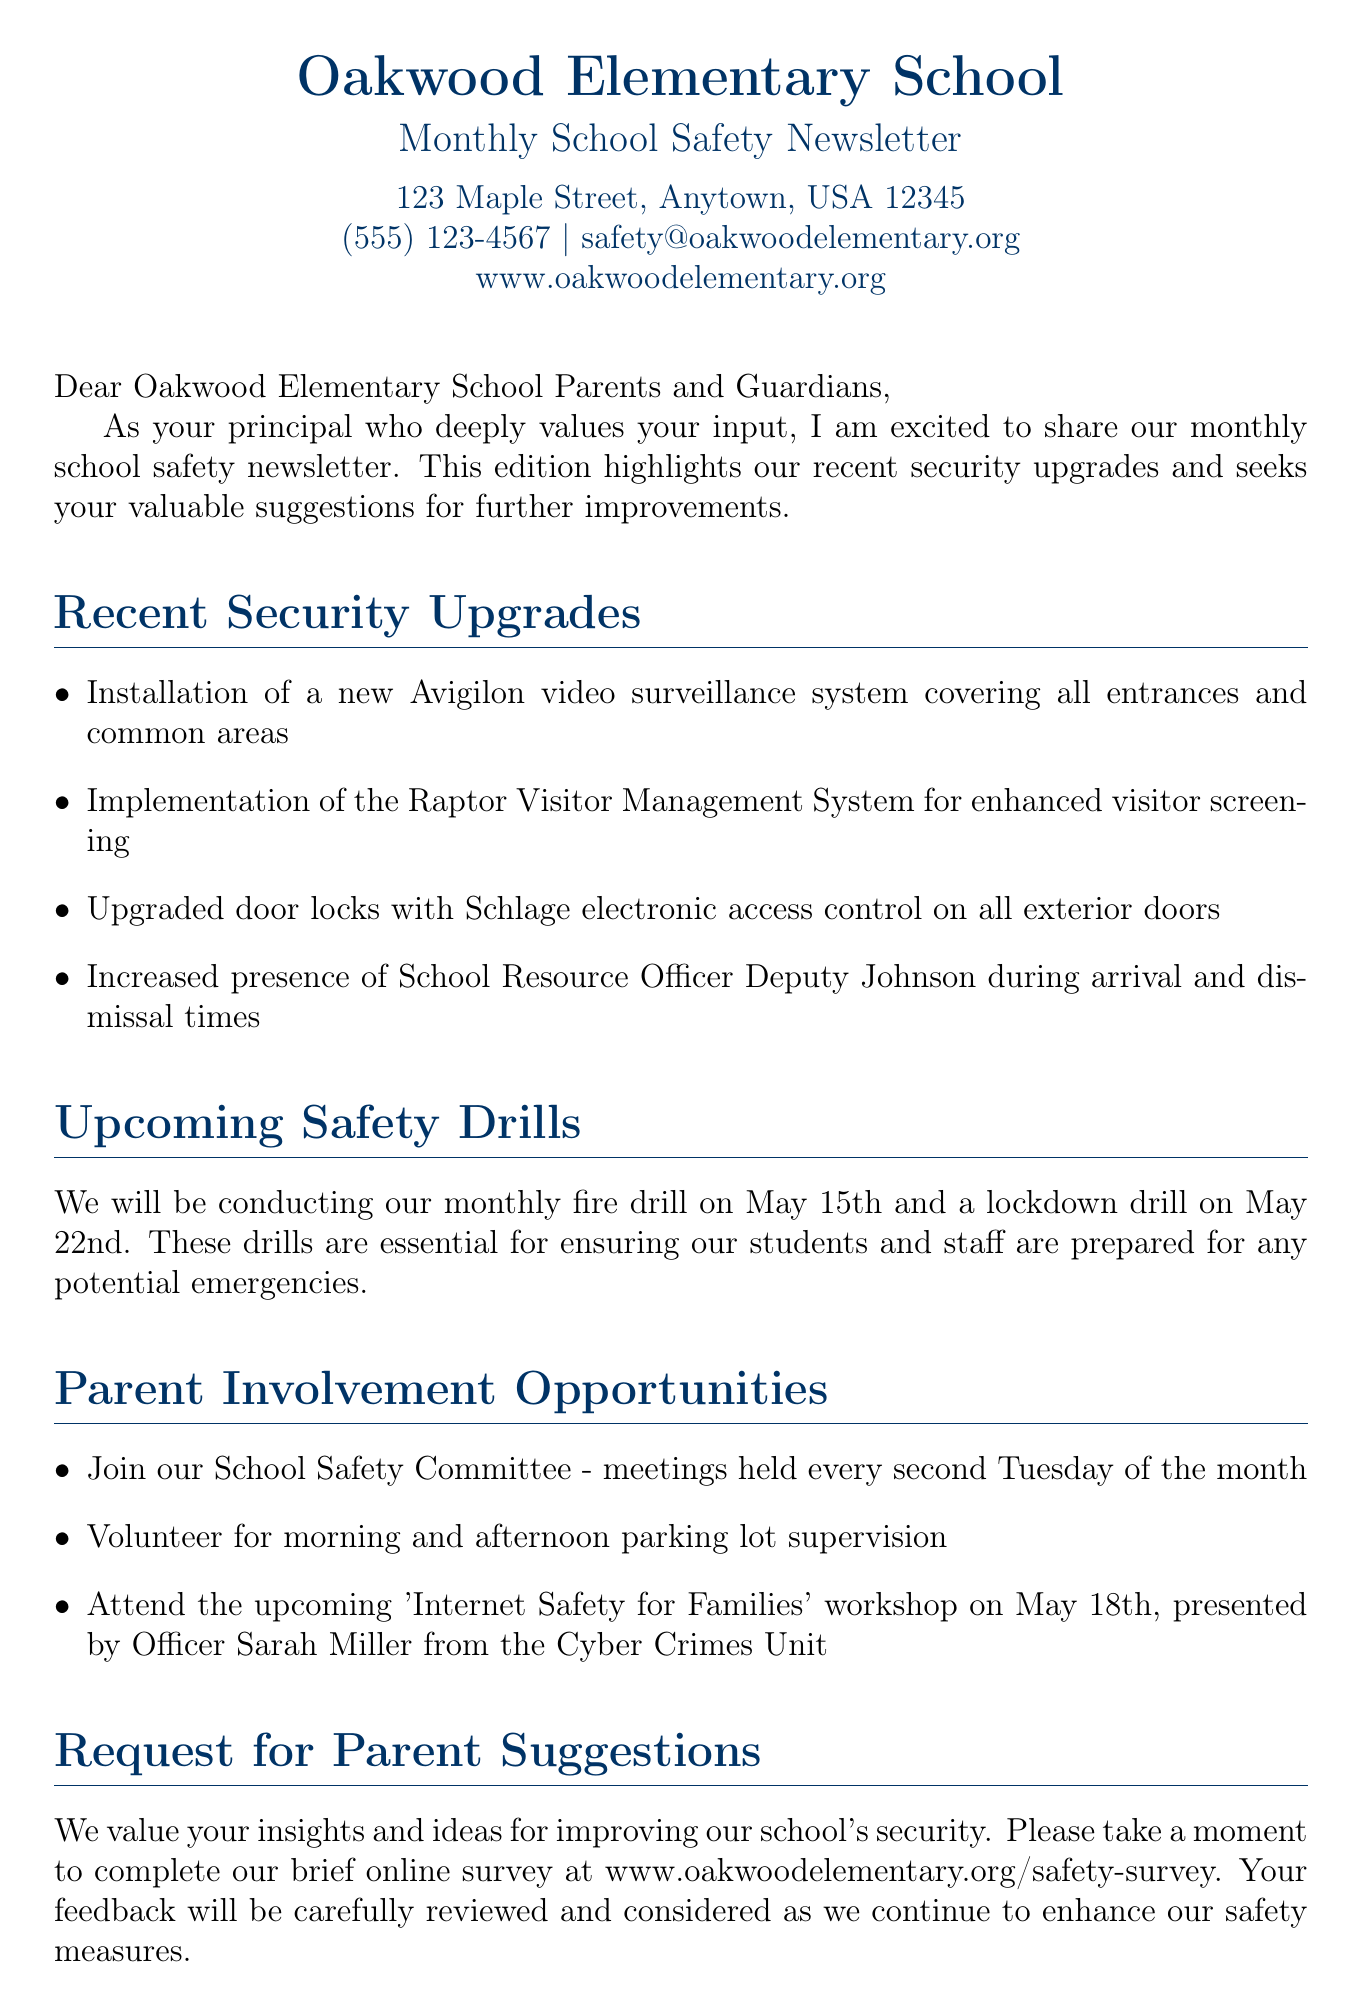What is the date of the fire drill? The fire drill is scheduled for May 15th, as mentioned in the Upcoming Safety Drills section.
Answer: May 15th Who is the School Resource Officer? The document states that Deputy Johnson is the School Resource Officer present during arrival and dismissal times.
Answer: Deputy Johnson What is the new visitor management system called? The document mentions the implementation of the Raptor Visitor Management System for enhanced visitor screening.
Answer: Raptor Visitor Management System When is the Internet Safety for Families workshop? The workshop is scheduled for May 18th, as indicated in the Parent Involvement Opportunities section.
Answer: May 18th What type of assessment is Secure Schools Alliance conducting? The newsletter states that Secure Schools Alliance will conduct a comprehensive safety assessment of our campus.
Answer: Comprehensive safety assessment How often does the School Safety Committee meet? The document notes that the School Safety Committee meets every second Tuesday of the month.
Answer: Every second Tuesday What method will parents use to provide security suggestions? The letter includes a brief online survey at a specified URL for parents to provide their feedback and suggestions.
Answer: Online survey How many recent security upgrades are listed? The letter outlines four recent security upgrades implemented at the school.
Answer: Four 